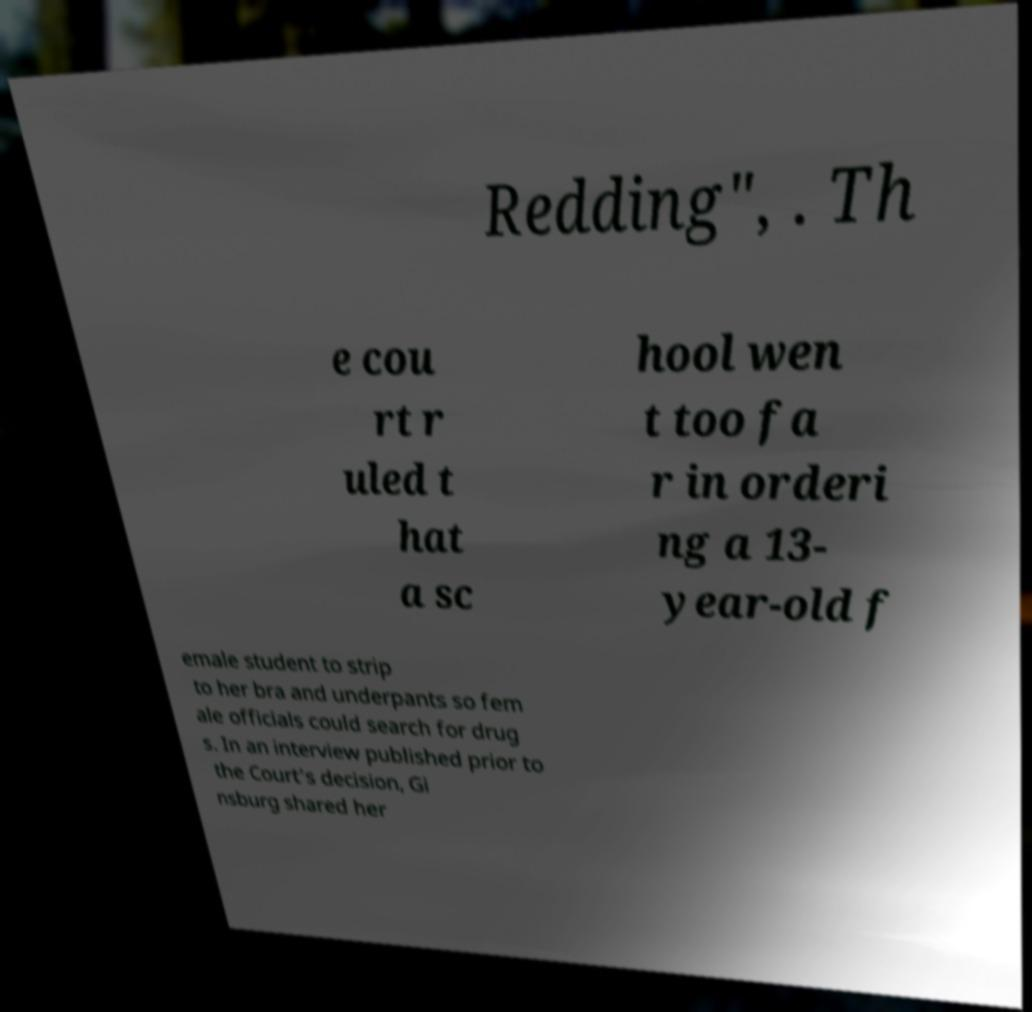I need the written content from this picture converted into text. Can you do that? Redding", . Th e cou rt r uled t hat a sc hool wen t too fa r in orderi ng a 13- year-old f emale student to strip to her bra and underpants so fem ale officials could search for drug s. In an interview published prior to the Court's decision, Gi nsburg shared her 